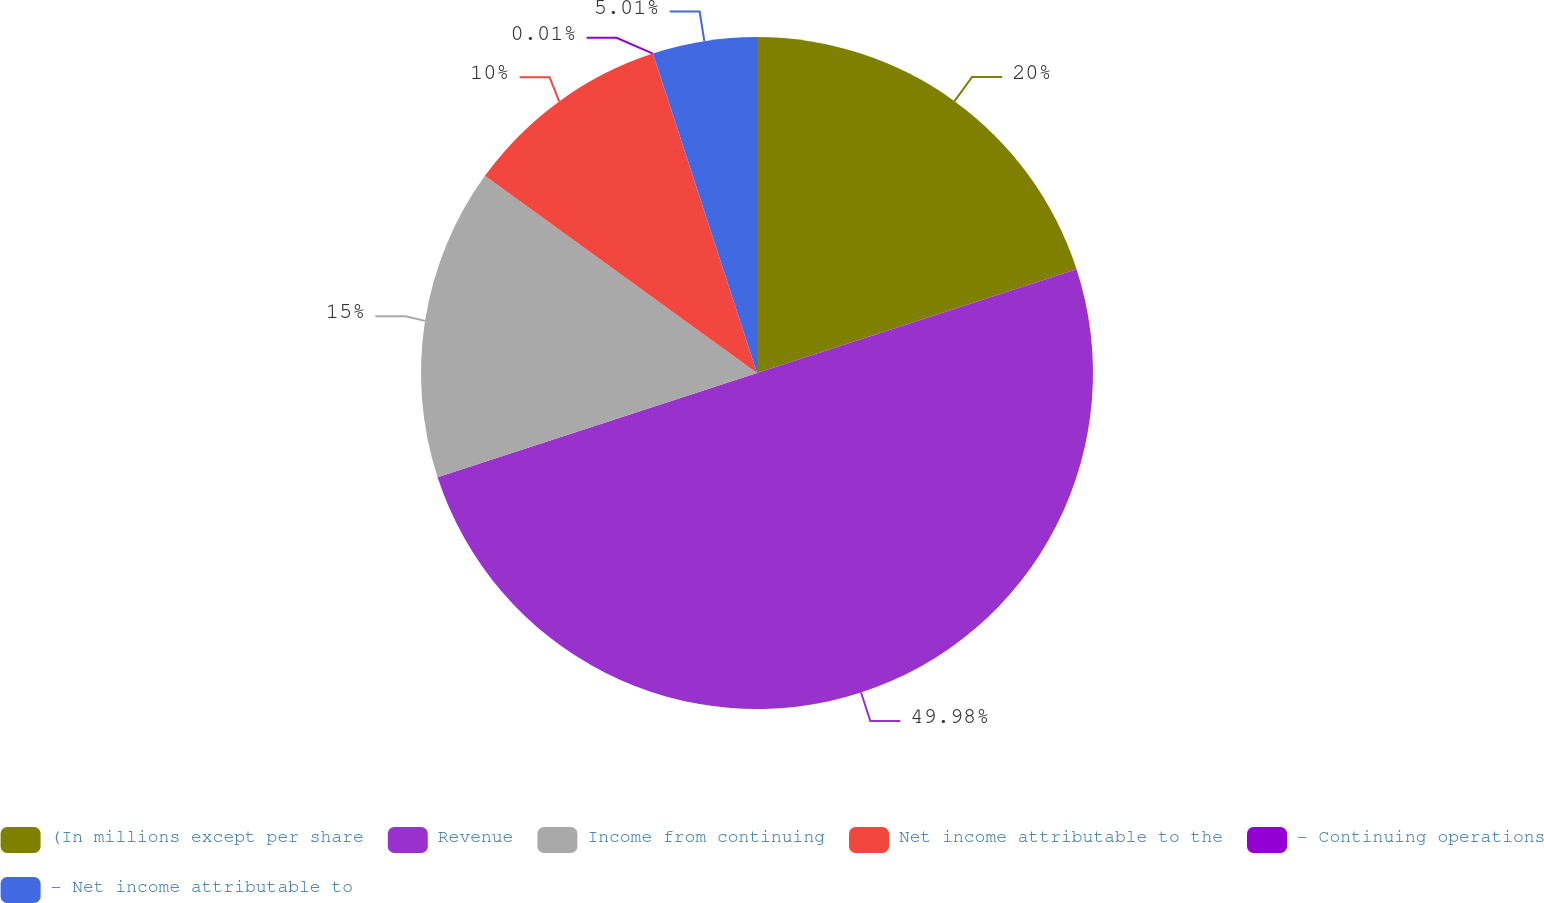Convert chart to OTSL. <chart><loc_0><loc_0><loc_500><loc_500><pie_chart><fcel>(In millions except per share<fcel>Revenue<fcel>Income from continuing<fcel>Net income attributable to the<fcel>- Continuing operations<fcel>- Net income attributable to<nl><fcel>20.0%<fcel>49.98%<fcel>15.0%<fcel>10.0%<fcel>0.01%<fcel>5.01%<nl></chart> 